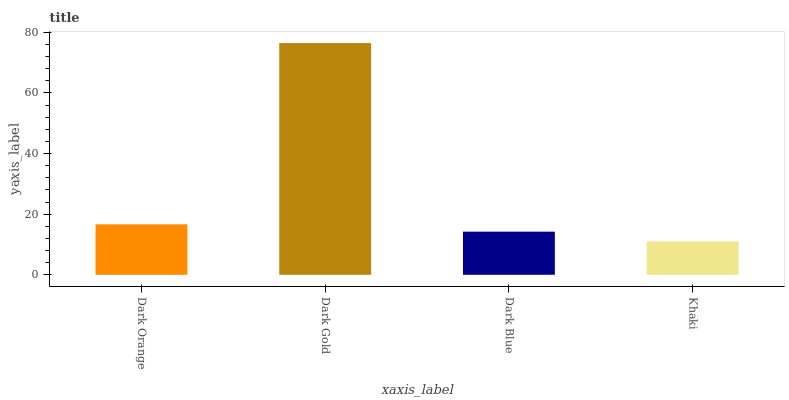Is Khaki the minimum?
Answer yes or no. Yes. Is Dark Gold the maximum?
Answer yes or no. Yes. Is Dark Blue the minimum?
Answer yes or no. No. Is Dark Blue the maximum?
Answer yes or no. No. Is Dark Gold greater than Dark Blue?
Answer yes or no. Yes. Is Dark Blue less than Dark Gold?
Answer yes or no. Yes. Is Dark Blue greater than Dark Gold?
Answer yes or no. No. Is Dark Gold less than Dark Blue?
Answer yes or no. No. Is Dark Orange the high median?
Answer yes or no. Yes. Is Dark Blue the low median?
Answer yes or no. Yes. Is Khaki the high median?
Answer yes or no. No. Is Khaki the low median?
Answer yes or no. No. 